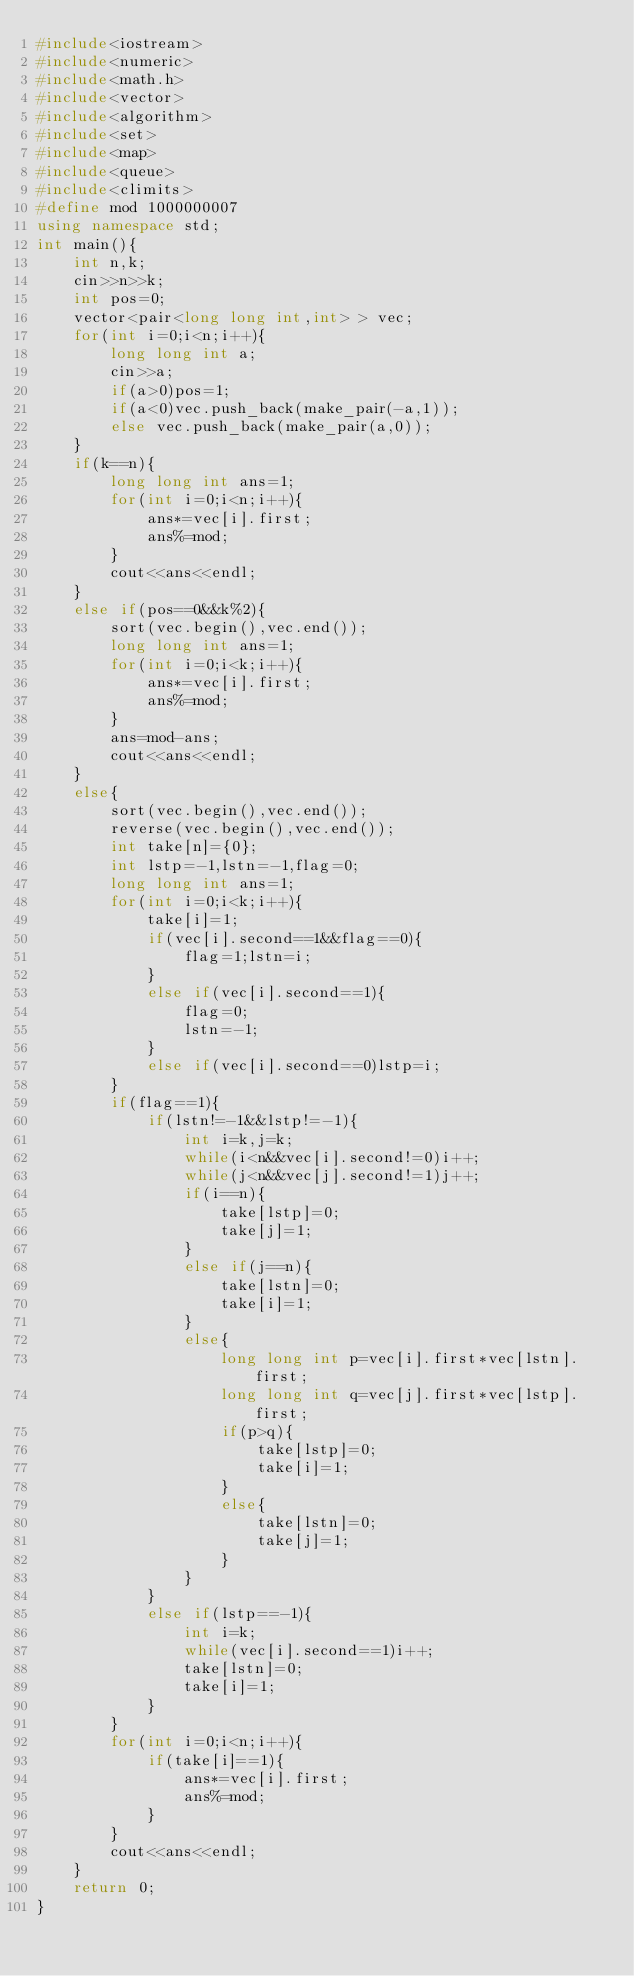Convert code to text. <code><loc_0><loc_0><loc_500><loc_500><_C++_>#include<iostream>
#include<numeric>
#include<math.h>
#include<vector>
#include<algorithm>
#include<set>
#include<map>
#include<queue>
#include<climits>
#define mod 1000000007
using namespace std;
int main(){
	int n,k;
	cin>>n>>k;
	int pos=0;
	vector<pair<long long int,int> > vec;
	for(int i=0;i<n;i++){
		long long int a;
		cin>>a;
		if(a>0)pos=1;
		if(a<0)vec.push_back(make_pair(-a,1));
		else vec.push_back(make_pair(a,0));
	}
	if(k==n){
		long long int ans=1;
		for(int i=0;i<n;i++){
			ans*=vec[i].first;
			ans%=mod;
		}
		cout<<ans<<endl;
	}
	else if(pos==0&&k%2){
		sort(vec.begin(),vec.end());
		long long int ans=1;
		for(int i=0;i<k;i++){
			ans*=vec[i].first;
			ans%=mod;
		}
		ans=mod-ans;
		cout<<ans<<endl;
	}
	else{
		sort(vec.begin(),vec.end());
		reverse(vec.begin(),vec.end());
		int take[n]={0};
		int lstp=-1,lstn=-1,flag=0;
		long long int ans=1;
		for(int i=0;i<k;i++){
			take[i]=1;
			if(vec[i].second==1&&flag==0){
				flag=1;lstn=i;
			}
			else if(vec[i].second==1){
				flag=0;
				lstn=-1;
			}
			else if(vec[i].second==0)lstp=i;
		}
		if(flag==1){
			if(lstn!=-1&&lstp!=-1){
				int i=k,j=k;
				while(i<n&&vec[i].second!=0)i++;
				while(j<n&&vec[j].second!=1)j++;
				if(i==n){
					take[lstp]=0;
					take[j]=1;
				}
				else if(j==n){
					take[lstn]=0;
					take[i]=1;
				}
				else{
					long long int p=vec[i].first*vec[lstn].first;
					long long int q=vec[j].first*vec[lstp].first;
					if(p>q){
						take[lstp]=0;
						take[i]=1;
					}
					else{
						take[lstn]=0;
						take[j]=1;
					}
				}
			}
			else if(lstp==-1){
				int i=k;
				while(vec[i].second==1)i++;
				take[lstn]=0;
				take[i]=1;
			}
		}
		for(int i=0;i<n;i++){
			if(take[i]==1){
				ans*=vec[i].first;
				ans%=mod;
			}
		}
		cout<<ans<<endl;
	}
	return 0;
} </code> 